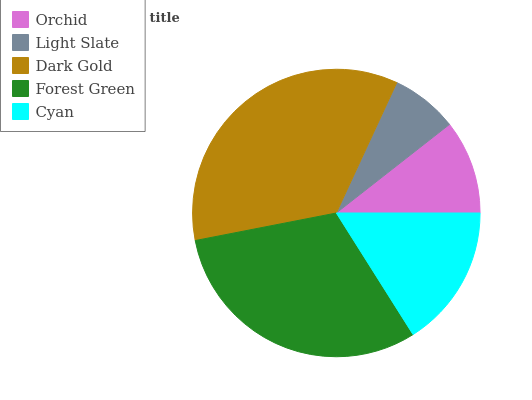Is Light Slate the minimum?
Answer yes or no. Yes. Is Dark Gold the maximum?
Answer yes or no. Yes. Is Dark Gold the minimum?
Answer yes or no. No. Is Light Slate the maximum?
Answer yes or no. No. Is Dark Gold greater than Light Slate?
Answer yes or no. Yes. Is Light Slate less than Dark Gold?
Answer yes or no. Yes. Is Light Slate greater than Dark Gold?
Answer yes or no. No. Is Dark Gold less than Light Slate?
Answer yes or no. No. Is Cyan the high median?
Answer yes or no. Yes. Is Cyan the low median?
Answer yes or no. Yes. Is Dark Gold the high median?
Answer yes or no. No. Is Orchid the low median?
Answer yes or no. No. 